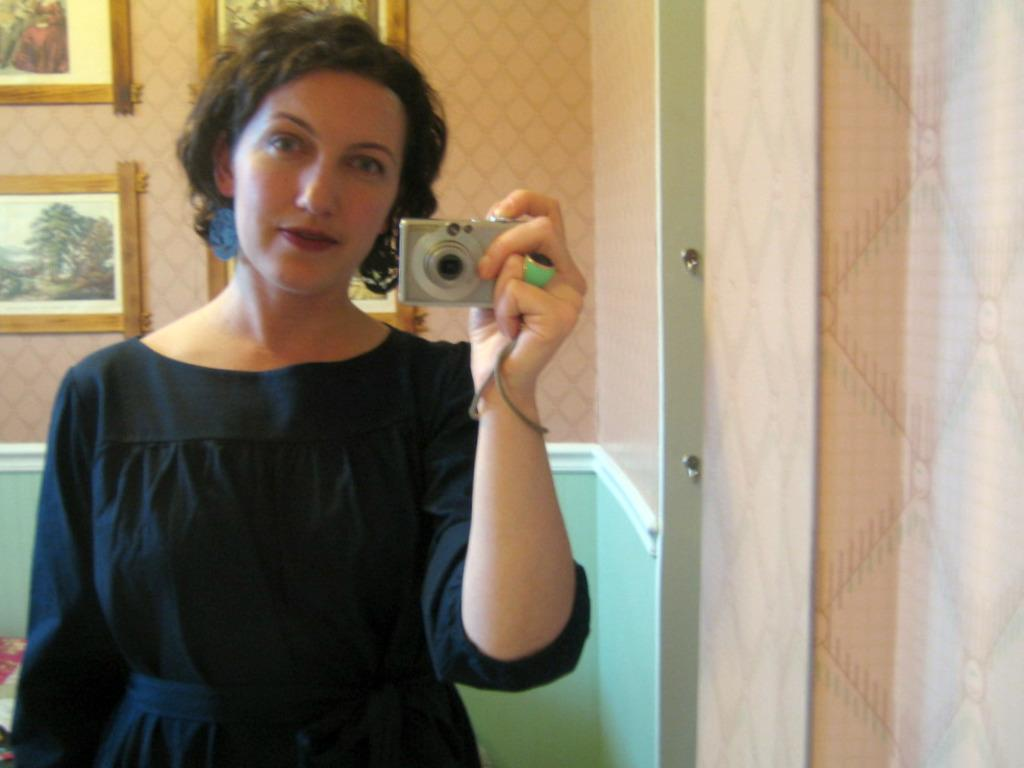What is the woman in the image doing? The woman is standing in the image and holding a camera. What can be seen on the wall in the background? There are photo frames on the wall in the background. What is the woman wearing? The woman is wearing a black dress. What type of food is the woman preparing in the image? There is no food visible in the image, and the woman is not preparing any food. What kind of board is the woman using to take the photo? The woman is holding a camera, not a board, to take the photo. 